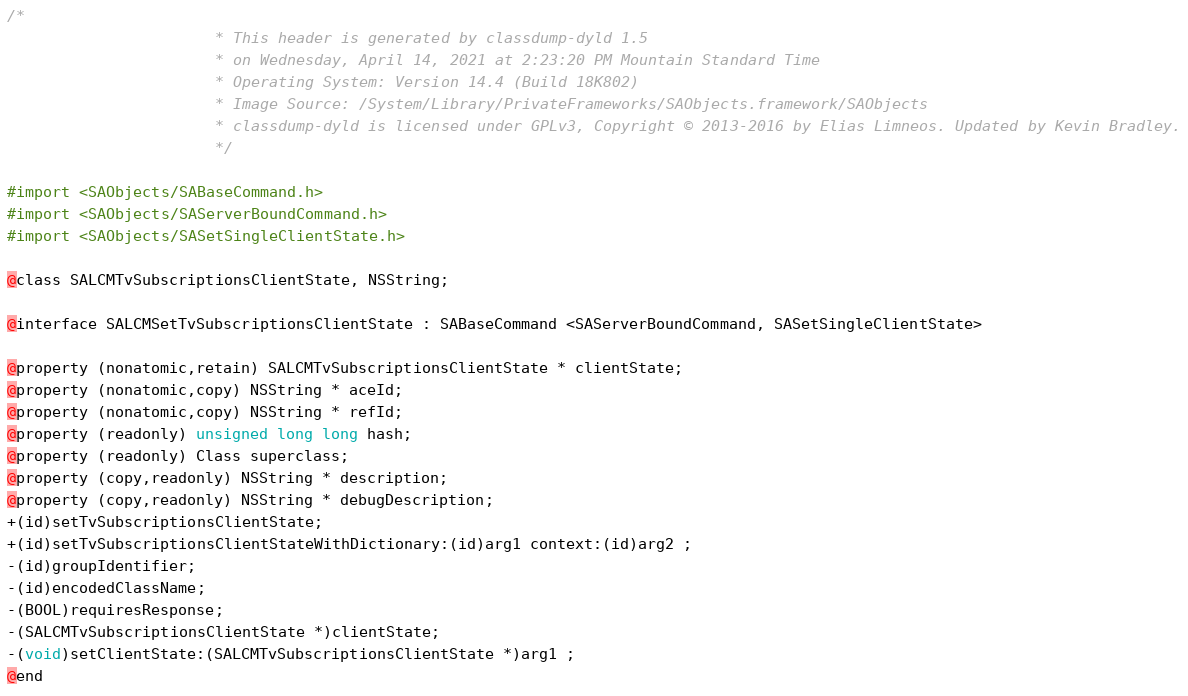<code> <loc_0><loc_0><loc_500><loc_500><_C_>/*
                       * This header is generated by classdump-dyld 1.5
                       * on Wednesday, April 14, 2021 at 2:23:20 PM Mountain Standard Time
                       * Operating System: Version 14.4 (Build 18K802)
                       * Image Source: /System/Library/PrivateFrameworks/SAObjects.framework/SAObjects
                       * classdump-dyld is licensed under GPLv3, Copyright © 2013-2016 by Elias Limneos. Updated by Kevin Bradley.
                       */

#import <SAObjects/SABaseCommand.h>
#import <SAObjects/SAServerBoundCommand.h>
#import <SAObjects/SASetSingleClientState.h>

@class SALCMTvSubscriptionsClientState, NSString;

@interface SALCMSetTvSubscriptionsClientState : SABaseCommand <SAServerBoundCommand, SASetSingleClientState>

@property (nonatomic,retain) SALCMTvSubscriptionsClientState * clientState; 
@property (nonatomic,copy) NSString * aceId; 
@property (nonatomic,copy) NSString * refId; 
@property (readonly) unsigned long long hash; 
@property (readonly) Class superclass; 
@property (copy,readonly) NSString * description; 
@property (copy,readonly) NSString * debugDescription; 
+(id)setTvSubscriptionsClientState;
+(id)setTvSubscriptionsClientStateWithDictionary:(id)arg1 context:(id)arg2 ;
-(id)groupIdentifier;
-(id)encodedClassName;
-(BOOL)requiresResponse;
-(SALCMTvSubscriptionsClientState *)clientState;
-(void)setClientState:(SALCMTvSubscriptionsClientState *)arg1 ;
@end

</code> 